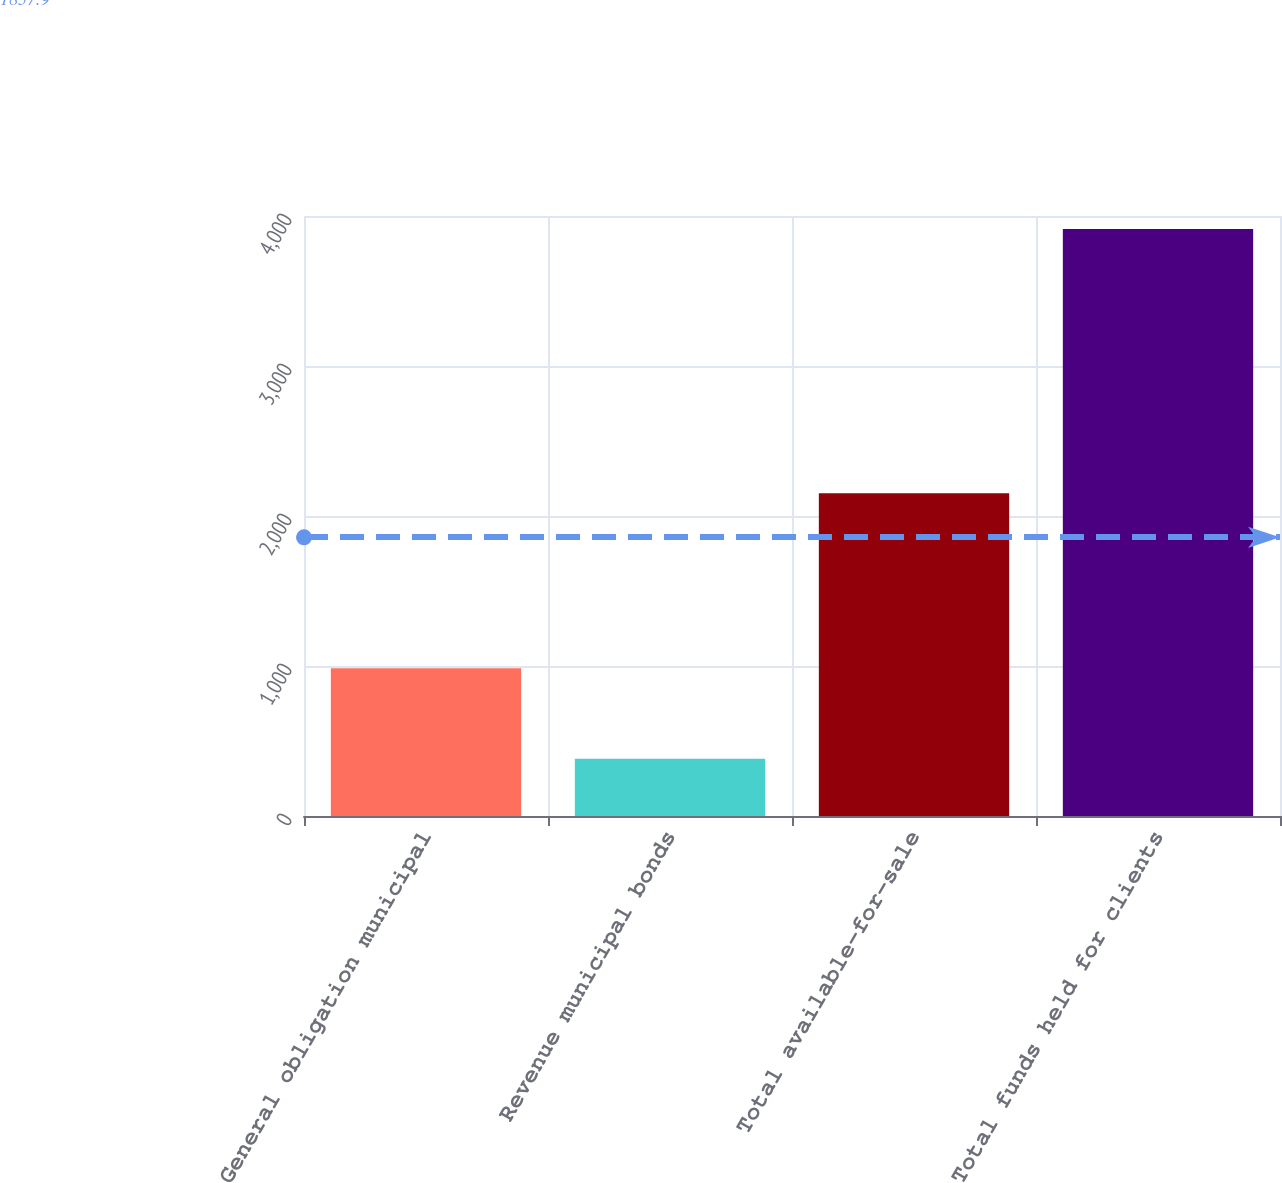<chart> <loc_0><loc_0><loc_500><loc_500><bar_chart><fcel>General obligation municipal<fcel>Revenue municipal bonds<fcel>Total available-for-sale<fcel>Total funds held for clients<nl><fcel>984.5<fcel>381.7<fcel>2151.8<fcel>3913.6<nl></chart> 